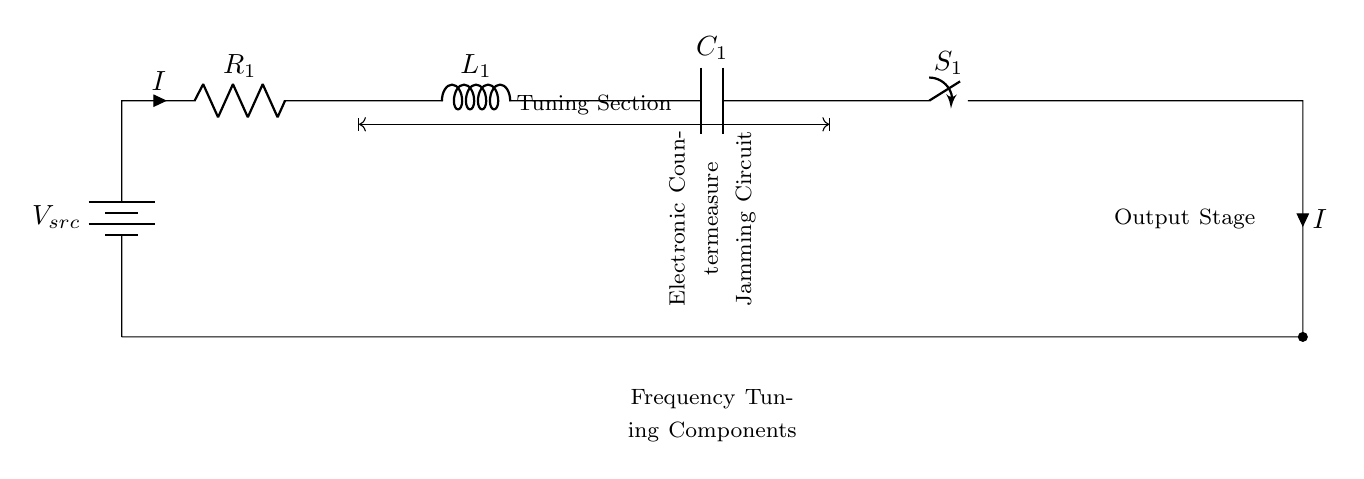What is the source voltage in the circuit? The source voltage is indicated by the label V_src at the battery component, which represents the power supply voltage for the circuit.
Answer: V_src What components are present in the tuning section? The tuning section includes a resistor R_1, an inductor L_1, and a capacitor C_1 that are connected in series, as indicated by their arrangement in the circuit.
Answer: R_1, L_1, C_1 What is the current direction through R_1? The current direction is indicated by the arrow labeled I, which shows that the current flows from the battery through R_1 toward the following components.
Answer: From battery to R_1 What happens if the switch S_1 is open? If the switch S_1 is open, it will break the circuit path, preventing current from flowing to the output stage and thus disabling the jamming function of the system.
Answer: No current flows What type of circuit is depicted in the diagram? The circuit is a series circuit because all components are connected end-to-end in a single path for current flow, as indicated by the positioning and connections of the components.
Answer: Series circuit How many main stages are identified in the circuit? The circuit can be divided into two main stages: the tuning section and the output stage, as labeled in the diagram with distinct areas for each function.
Answer: Two stages 